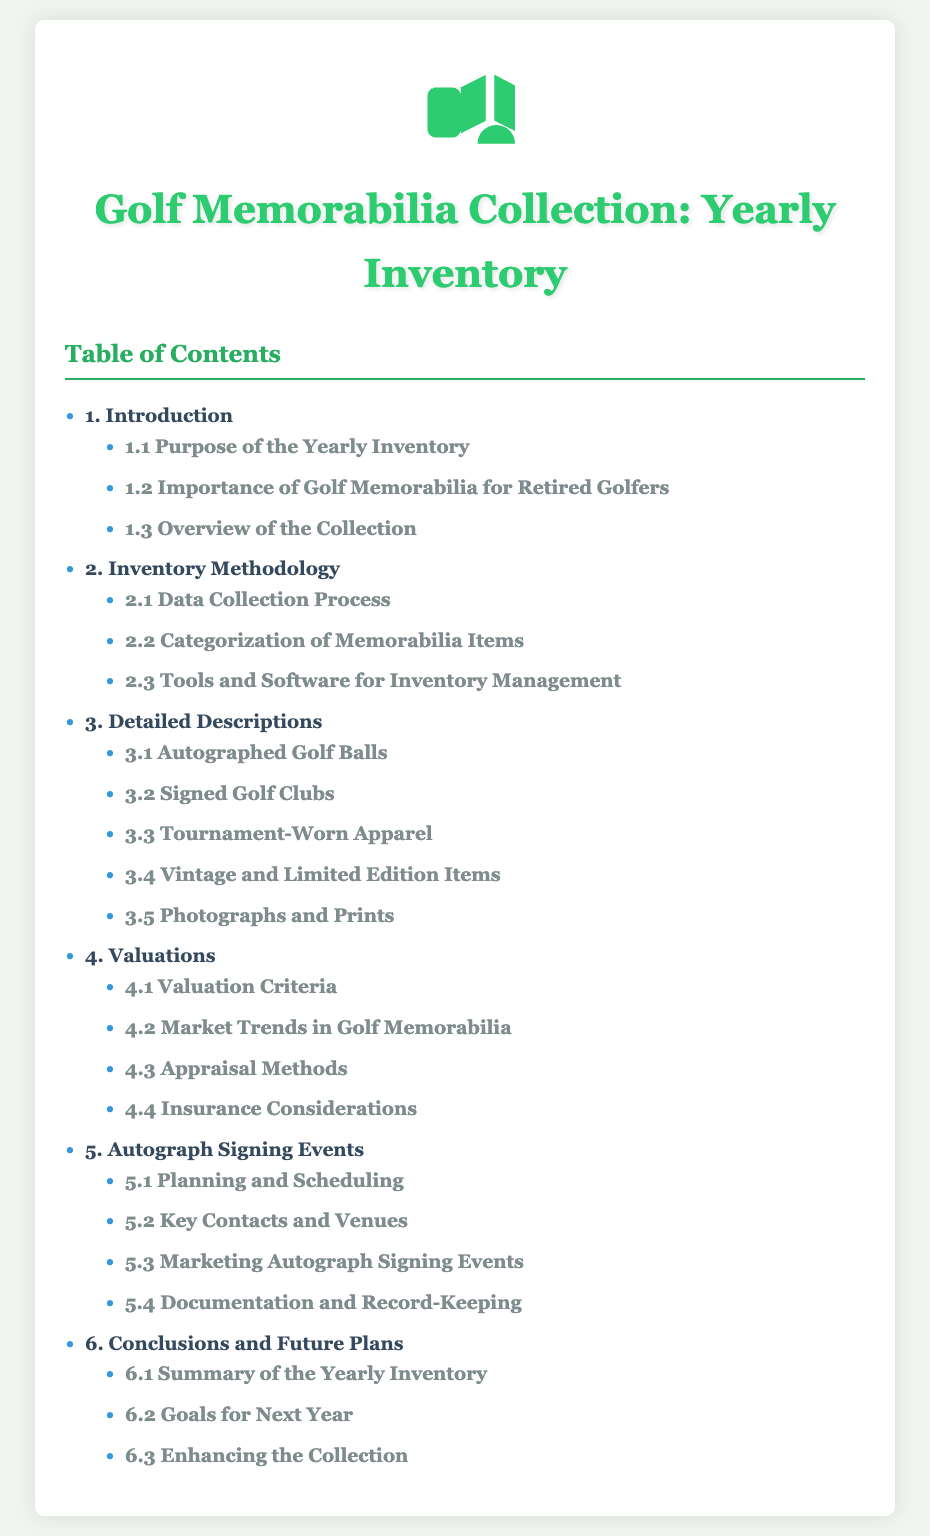what is the title of the document? The title is prominently displayed at the top of the document.
Answer: Golf Memorabilia Collection: Yearly Inventory what is the first chapter of the document? The first chapter is listed in the Table of Contents.
Answer: Introduction how many sections are listed under chapter 4? The document lists the number of sections under chapter 4 in the Table of Contents.
Answer: 4 name one type of memorabilia described in chapter 3. The document provides examples of memorabilia types in chapter 3.
Answer: Autographed Golf Balls what is the purpose of the yearly inventory? The purpose is defined in section 1.1 of chapter 1.
Answer: Purpose of the Yearly Inventory which chapter discusses insurance considerations? The chapter that includes this information can be identified from the Table of Contents.
Answer: Valuations how many chapters are there in the document? The total number of chapters can be counted from the Table of Contents.
Answer: 6 what are key contacts a part of? This information is categorized in the Table of Contents.
Answer: Autograph Signing Events what does section 6.2 focus on? The focus of section 6.2 is outlined in chapter 6 of the Table of Contents.
Answer: Goals for Next Year 